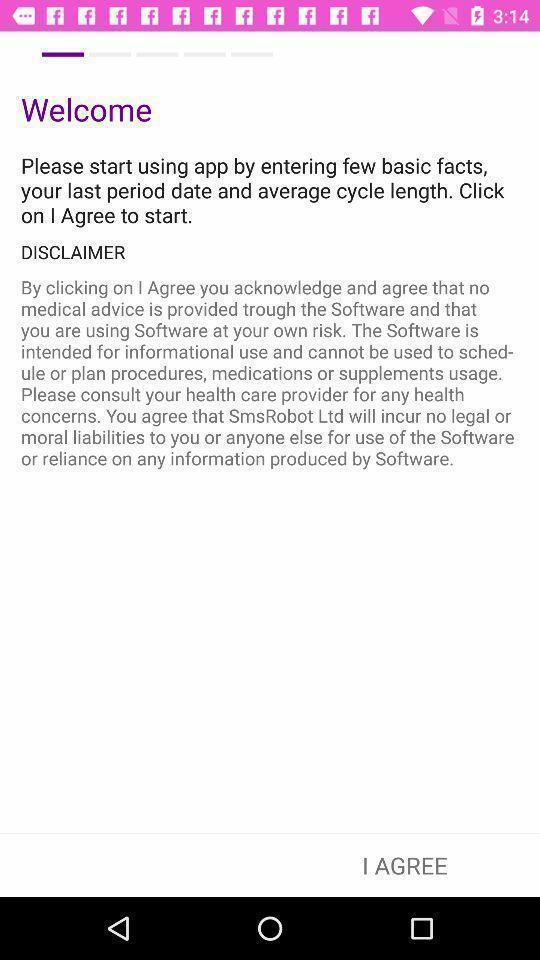Summarize the information in this screenshot. Welcome page. 